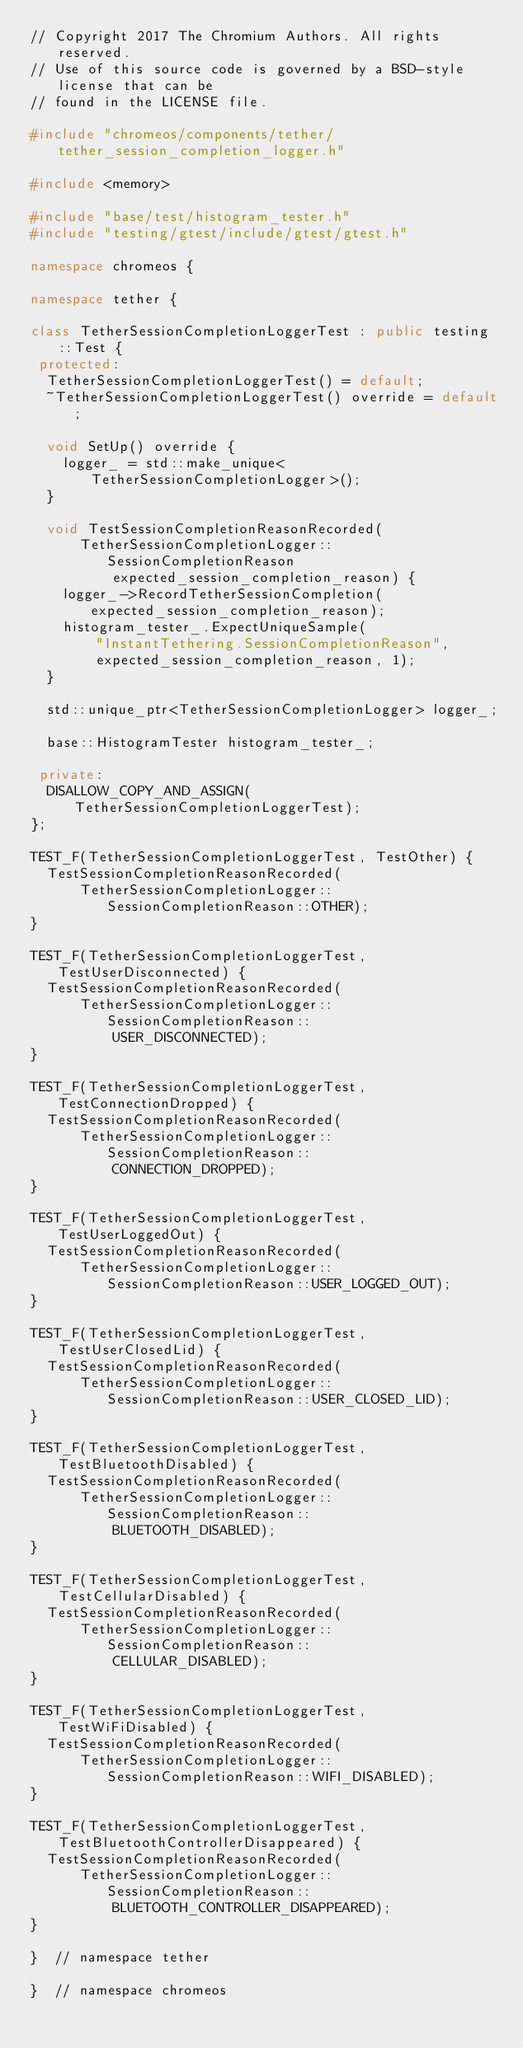Convert code to text. <code><loc_0><loc_0><loc_500><loc_500><_C++_>// Copyright 2017 The Chromium Authors. All rights reserved.
// Use of this source code is governed by a BSD-style license that can be
// found in the LICENSE file.

#include "chromeos/components/tether/tether_session_completion_logger.h"

#include <memory>

#include "base/test/histogram_tester.h"
#include "testing/gtest/include/gtest/gtest.h"

namespace chromeos {

namespace tether {

class TetherSessionCompletionLoggerTest : public testing::Test {
 protected:
  TetherSessionCompletionLoggerTest() = default;
  ~TetherSessionCompletionLoggerTest() override = default;

  void SetUp() override {
    logger_ = std::make_unique<TetherSessionCompletionLogger>();
  }

  void TestSessionCompletionReasonRecorded(
      TetherSessionCompletionLogger::SessionCompletionReason
          expected_session_completion_reason) {
    logger_->RecordTetherSessionCompletion(expected_session_completion_reason);
    histogram_tester_.ExpectUniqueSample(
        "InstantTethering.SessionCompletionReason",
        expected_session_completion_reason, 1);
  }

  std::unique_ptr<TetherSessionCompletionLogger> logger_;

  base::HistogramTester histogram_tester_;

 private:
  DISALLOW_COPY_AND_ASSIGN(TetherSessionCompletionLoggerTest);
};

TEST_F(TetherSessionCompletionLoggerTest, TestOther) {
  TestSessionCompletionReasonRecorded(
      TetherSessionCompletionLogger::SessionCompletionReason::OTHER);
}

TEST_F(TetherSessionCompletionLoggerTest, TestUserDisconnected) {
  TestSessionCompletionReasonRecorded(
      TetherSessionCompletionLogger::SessionCompletionReason::
          USER_DISCONNECTED);
}

TEST_F(TetherSessionCompletionLoggerTest, TestConnectionDropped) {
  TestSessionCompletionReasonRecorded(
      TetherSessionCompletionLogger::SessionCompletionReason::
          CONNECTION_DROPPED);
}

TEST_F(TetherSessionCompletionLoggerTest, TestUserLoggedOut) {
  TestSessionCompletionReasonRecorded(
      TetherSessionCompletionLogger::SessionCompletionReason::USER_LOGGED_OUT);
}

TEST_F(TetherSessionCompletionLoggerTest, TestUserClosedLid) {
  TestSessionCompletionReasonRecorded(
      TetherSessionCompletionLogger::SessionCompletionReason::USER_CLOSED_LID);
}

TEST_F(TetherSessionCompletionLoggerTest, TestBluetoothDisabled) {
  TestSessionCompletionReasonRecorded(
      TetherSessionCompletionLogger::SessionCompletionReason::
          BLUETOOTH_DISABLED);
}

TEST_F(TetherSessionCompletionLoggerTest, TestCellularDisabled) {
  TestSessionCompletionReasonRecorded(
      TetherSessionCompletionLogger::SessionCompletionReason::
          CELLULAR_DISABLED);
}

TEST_F(TetherSessionCompletionLoggerTest, TestWiFiDisabled) {
  TestSessionCompletionReasonRecorded(
      TetherSessionCompletionLogger::SessionCompletionReason::WIFI_DISABLED);
}

TEST_F(TetherSessionCompletionLoggerTest, TestBluetoothControllerDisappeared) {
  TestSessionCompletionReasonRecorded(
      TetherSessionCompletionLogger::SessionCompletionReason::
          BLUETOOTH_CONTROLLER_DISAPPEARED);
}

}  // namespace tether

}  // namespace chromeos
</code> 